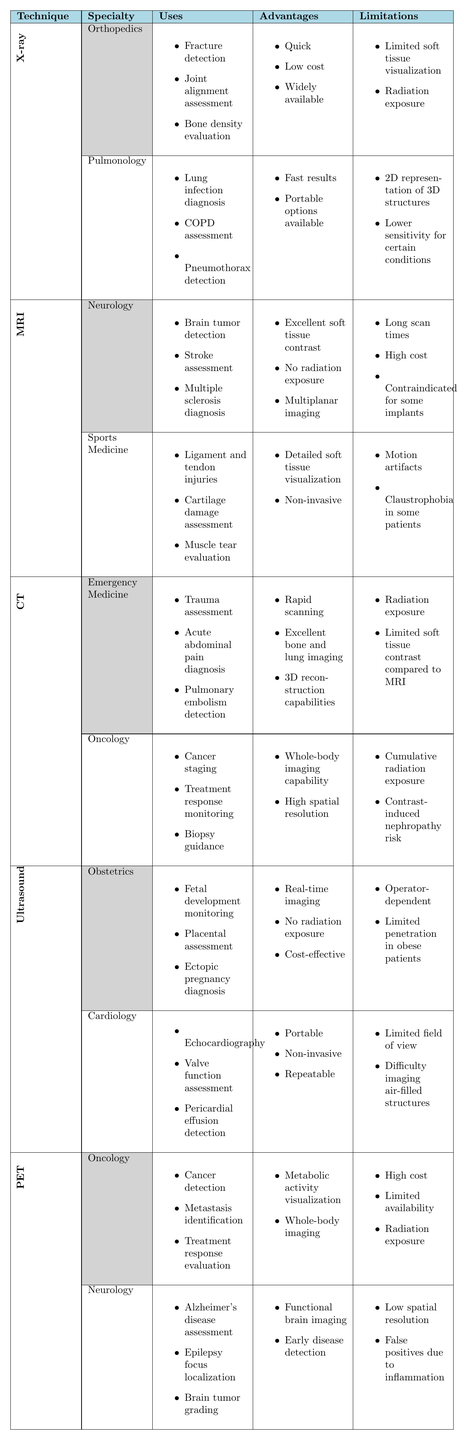What are the applications of MRI in neurology? According to the table, the applications of MRI in neurology include brain tumor detection, stroke assessment, and multiple sclerosis diagnosis.
Answer: Brain tumor detection, stroke assessment, multiple sclerosis diagnosis What are the advantages of using ultrasound in cardiology? The table lists the advantages of ultrasound in cardiology as being portable, non-invasive, and repeatable.
Answer: Portable, non-invasive, repeatable In which specialty is CT primarily used for trauma assessment? The table indicates that CT is primarily used for trauma assessment in the specialty of Emergency Medicine.
Answer: Emergency Medicine Which imaging technique has no radiation exposure? From the table, MRI and ultrasound both do not expose patients to radiation.
Answer: MRI and ultrasound What are the limitations of PET in oncology? The limitations of PET in oncology, as mentioned in the table, are high cost, limited availability, and radiation exposure.
Answer: High cost, limited availability, radiation exposure How many advantages does X-ray have listed in the table? The table shows that X-ray has three advantages: quick, low cost, and widely available. Thus, the total is three advantages.
Answer: Three Which medical imaging technique has the longest scan times? According to the table, MRI is mentioned to have long scan times as one of its limitations.
Answer: MRI In which specialty is ultrasound used for fetal development monitoring? The table states that ultrasound is used for fetal development monitoring in the specialty of Obstetrics.
Answer: Obstetrics Does MRI have a higher cost than CT? The table indicates that MRI is high cost, while CT does not specify a cost concern as a limitation. Thus, we can infer MRI has a higher cost.
Answer: Yes What is the primary use of CT in oncology according to the table? The primary use of CT in oncology, as detailed in the table, includes cancer staging, treatment response monitoring, and biopsy guidance.
Answer: Cancer staging, treatment response monitoring, biopsy guidance Which technique is most suitable for soft tissue visualization? The table highlights that MRI offers excellent soft tissue contrast, meaning it is most suitable for soft tissue visualization.
Answer: MRI 